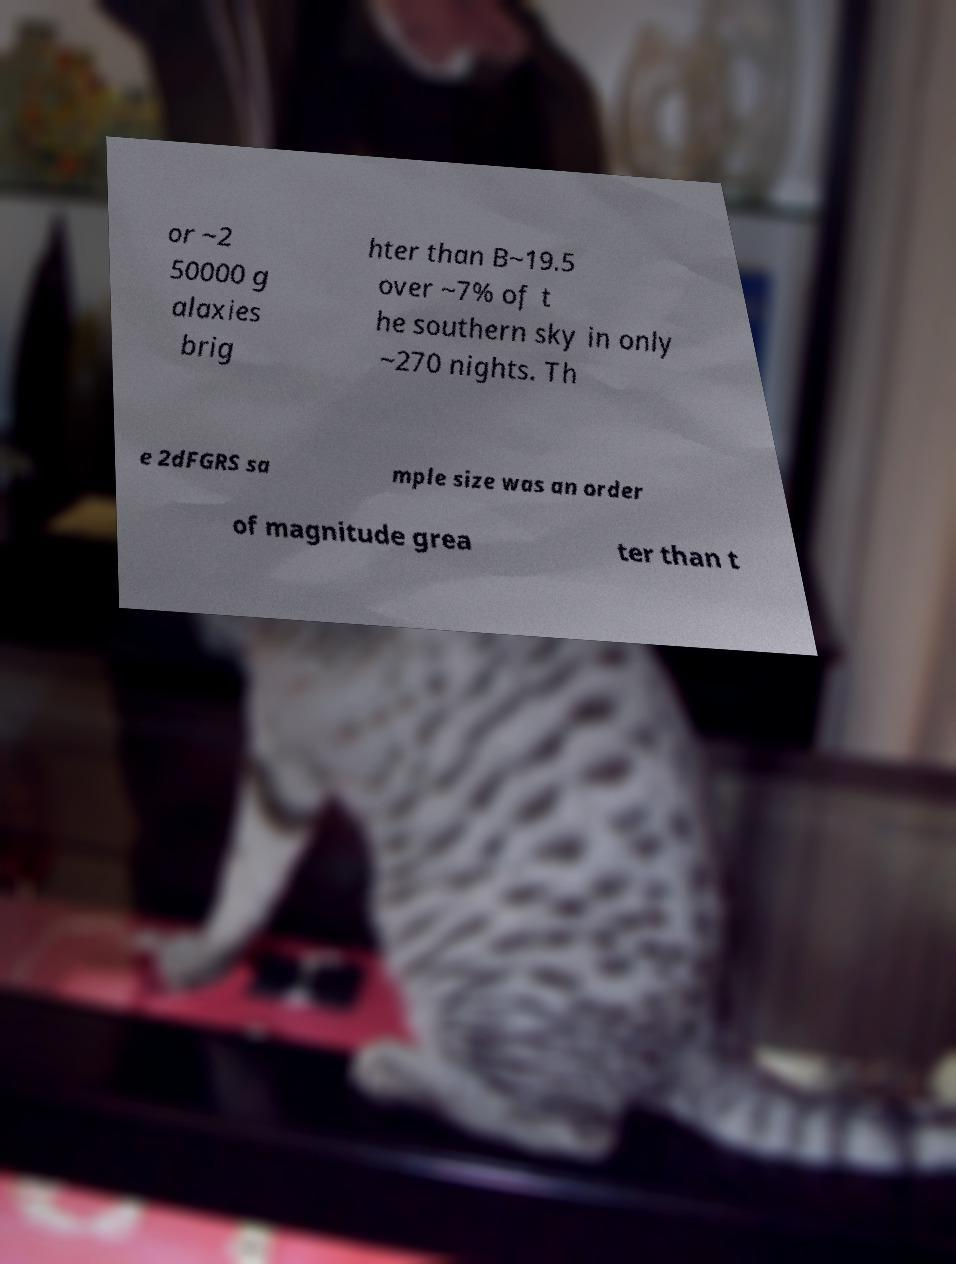Please identify and transcribe the text found in this image. or ~2 50000 g alaxies brig hter than B~19.5 over ~7% of t he southern sky in only ~270 nights. Th e 2dFGRS sa mple size was an order of magnitude grea ter than t 